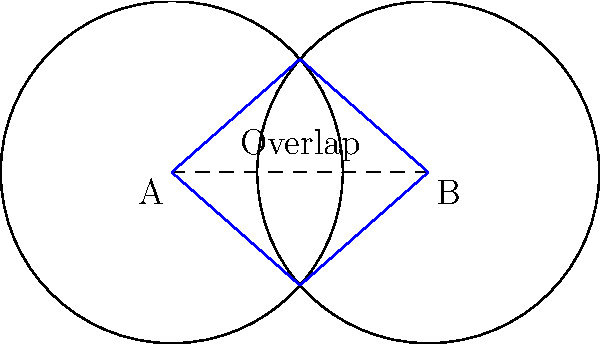In a social media platform, user interaction zones are represented by circles. Two users, A and B, have interaction zones with a radius of 2 units. If the centers of their zones are 3 units apart, what is the area of the overlapping region where both users can interact? To find the area of the overlapping region between two circles, we need to follow these steps:

1) First, we need to calculate the angle $\theta$ formed at the center of each circle by the overlap:
   $$\theta = 2 \arccos(\frac{d}{2r})$$
   where $d$ is the distance between centers and $r$ is the radius.

2) Here, $d = 3$ and $r = 2$. So:
   $$\theta = 2 \arccos(\frac{3}{2(2)}) = 2 \arccos(0.75) \approx 1.5708$$

3) The area of the sector formed in each circle is:
   $$A_{sector} = \frac{1}{2}r^2\theta$$

4) The area of the triangle formed in each circle is:
   $$A_{triangle} = \frac{1}{2}r^2\sin(\theta)$$

5) The area of the overlap is twice the difference between the sector and triangle:
   $$A_{overlap} = 2(A_{sector} - A_{triangle})$$
   $$= 2(\frac{1}{2}r^2\theta - \frac{1}{2}r^2\sin(\theta))$$
   $$= r^2(\theta - \sin(\theta))$$

6) Substituting our values:
   $$A_{overlap} = 2^2(1.5708 - \sin(1.5708))$$
   $$\approx 1.2284$$

Therefore, the area of the overlapping region is approximately 1.2284 square units.
Answer: 1.2284 square units 